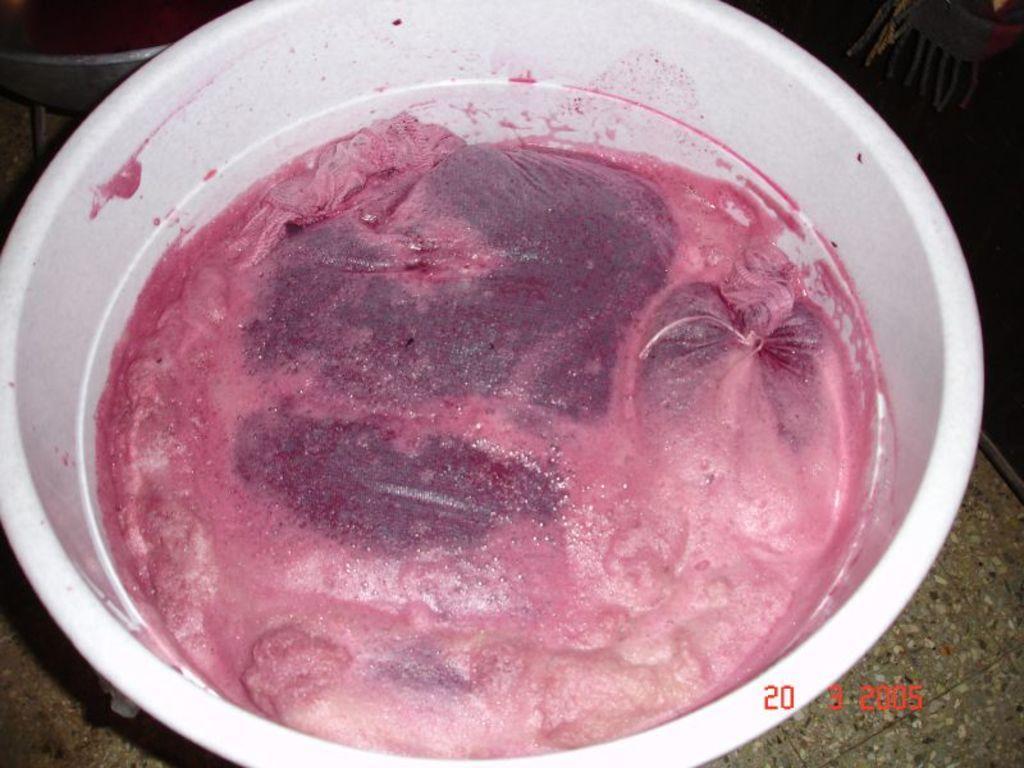Could you give a brief overview of what you see in this image? In this image there is a food item in a plastic bowl. 